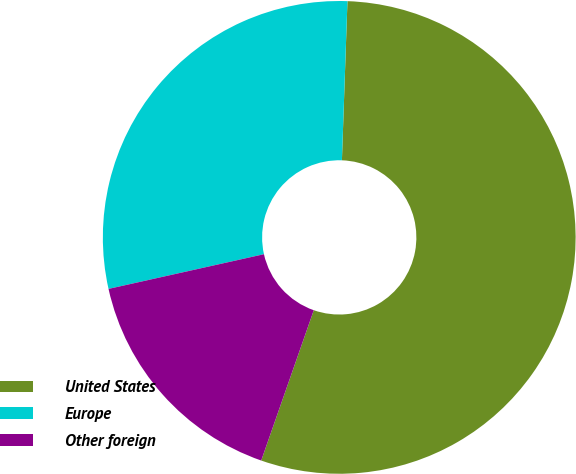Convert chart to OTSL. <chart><loc_0><loc_0><loc_500><loc_500><pie_chart><fcel>United States<fcel>Europe<fcel>Other foreign<nl><fcel>54.8%<fcel>29.05%<fcel>16.15%<nl></chart> 